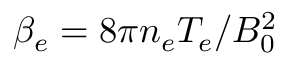Convert formula to latex. <formula><loc_0><loc_0><loc_500><loc_500>\beta _ { e } = 8 \pi n _ { e } T _ { e } / B _ { 0 } ^ { 2 }</formula> 